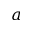<formula> <loc_0><loc_0><loc_500><loc_500>a</formula> 